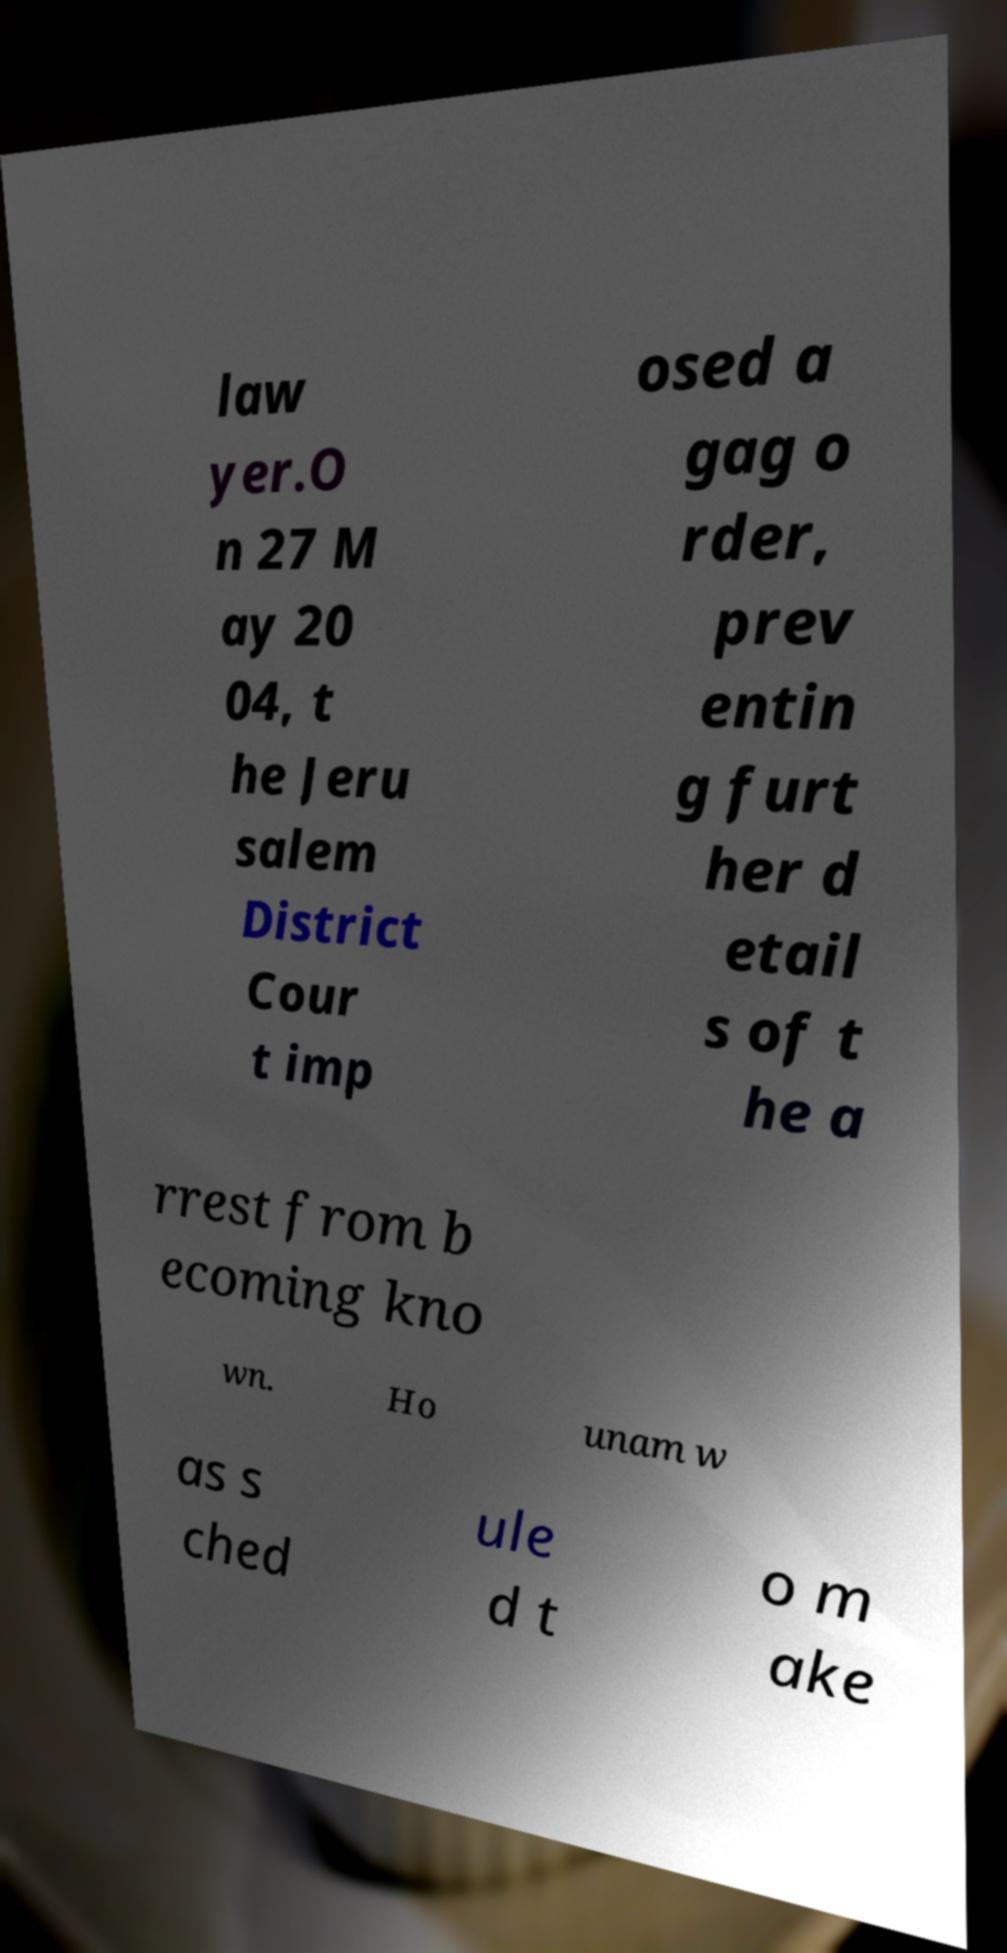What messages or text are displayed in this image? I need them in a readable, typed format. law yer.O n 27 M ay 20 04, t he Jeru salem District Cour t imp osed a gag o rder, prev entin g furt her d etail s of t he a rrest from b ecoming kno wn. Ho unam w as s ched ule d t o m ake 